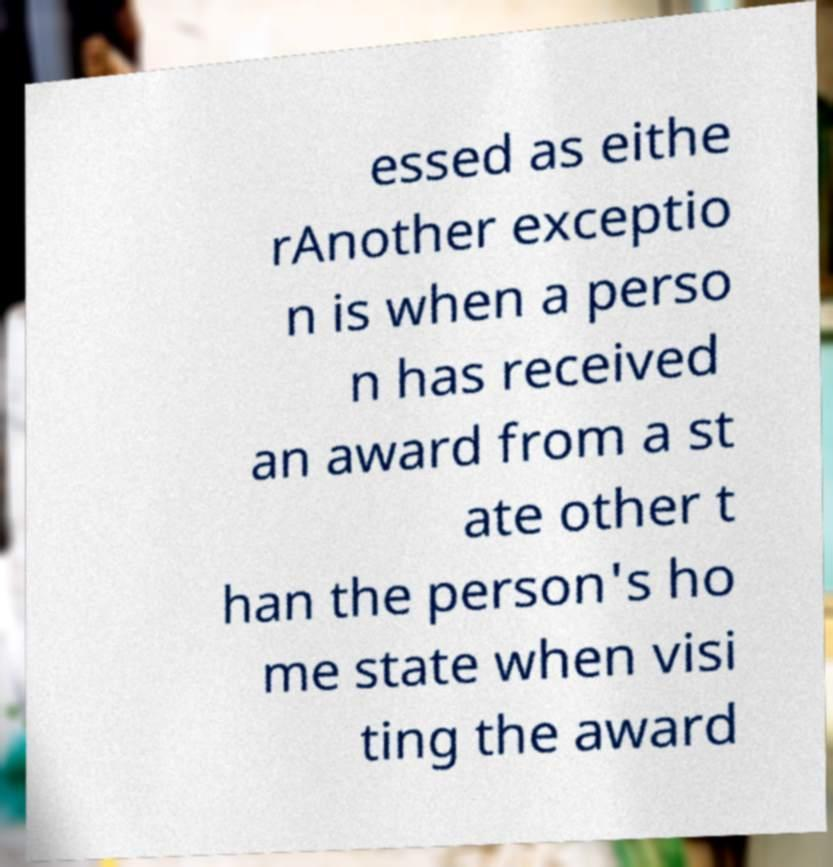Please identify and transcribe the text found in this image. essed as eithe rAnother exceptio n is when a perso n has received an award from a st ate other t han the person's ho me state when visi ting the award 